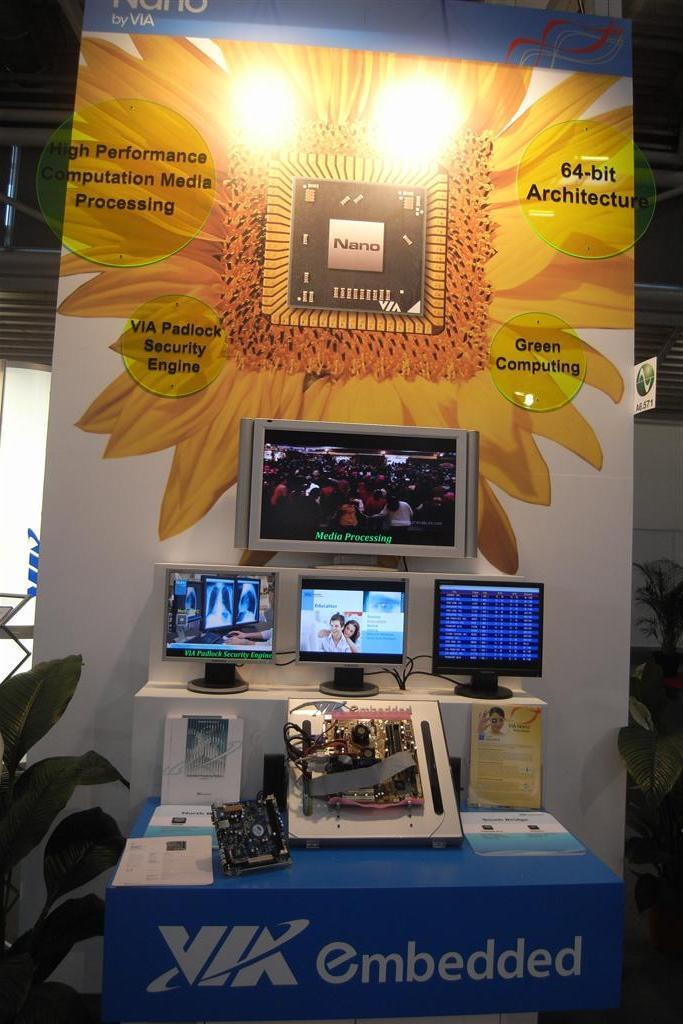<image>
Give a short and clear explanation of the subsequent image. A display for VIK embedded has several monitors and the image of a flower. 